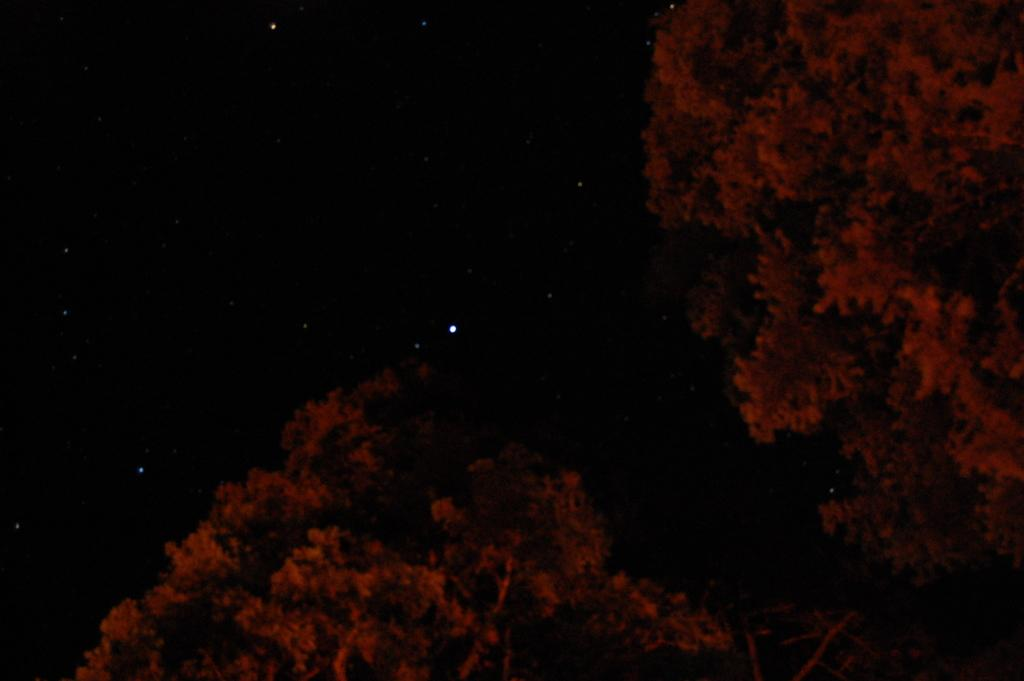What type of vegetation can be seen in the bottom and right corner of the image? There are trees in the bottom and right corner of the image. What is the color of the sky in the background of the image? The sky in the background of the image is black. Are there any celestial bodies visible in the sky? Yes, there are stars visible in the black sky. What type of substance is being used to create the wire in the image? There is no wire present in the image; it features trees and a black sky with stars. 